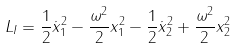Convert formula to latex. <formula><loc_0><loc_0><loc_500><loc_500>L _ { I } = \frac { 1 } { 2 } \dot { x } _ { 1 } ^ { 2 } - \frac { \omega ^ { 2 } } { 2 } x _ { 1 } ^ { 2 } - \frac { 1 } { 2 } \dot { x } _ { 2 } ^ { 2 } + \frac { \omega ^ { 2 } } { 2 } x _ { 2 } ^ { 2 }</formula> 